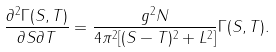<formula> <loc_0><loc_0><loc_500><loc_500>\frac { \partial ^ { 2 } \Gamma ( S , T ) } { \partial S \partial T } = \frac { g ^ { 2 } N } { 4 \pi ^ { 2 } [ ( S - T ) ^ { 2 } + L ^ { 2 } ] } \Gamma ( S , T ) .</formula> 